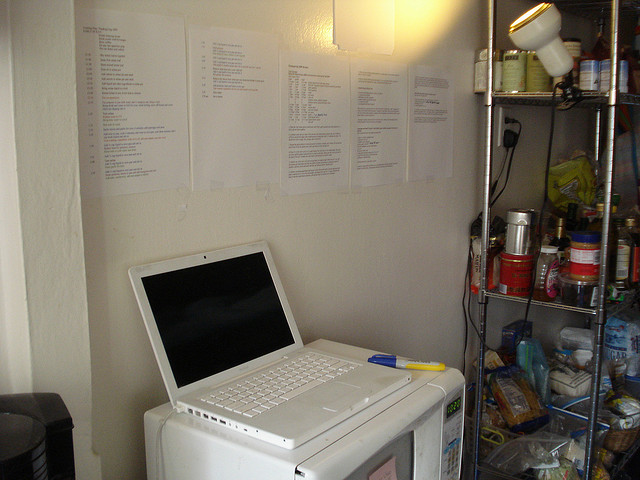Where is the microwave oven located? The microwave oven is positioned on the bottom left of the image, with a laptop placed on top of it. 